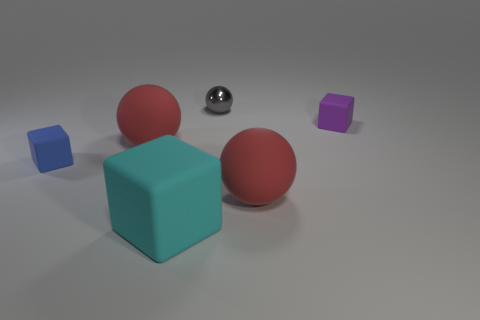Add 1 red matte spheres. How many objects exist? 7 Subtract 1 blue cubes. How many objects are left? 5 Subtract all big green metal balls. Subtract all purple rubber objects. How many objects are left? 5 Add 3 big cubes. How many big cubes are left? 4 Add 4 tiny purple rubber cubes. How many tiny purple rubber cubes exist? 5 